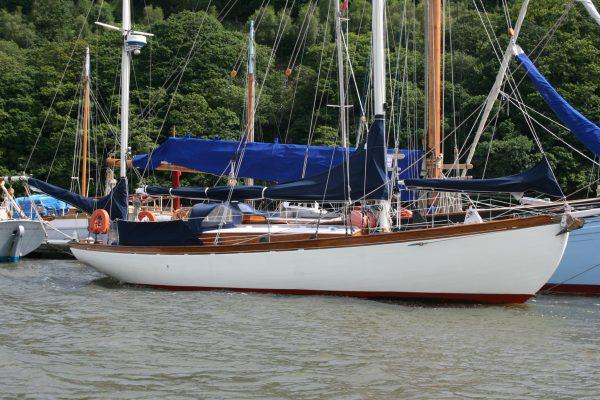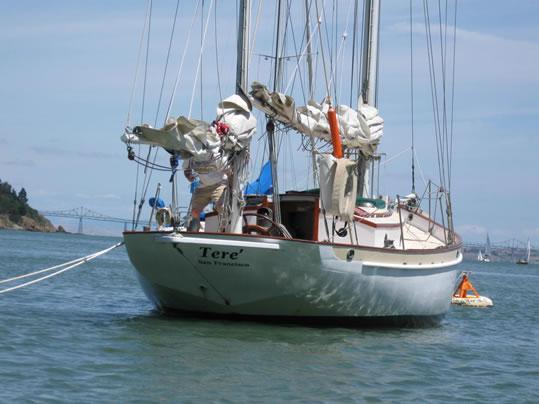The first image is the image on the left, the second image is the image on the right. Considering the images on both sides, is "The image on the left has a boat with at least three of its sails engaged." valid? Answer yes or no. No. The first image is the image on the left, the second image is the image on the right. Given the left and right images, does the statement "There is a sailboat going left with at least two passengers in the boat." hold true? Answer yes or no. No. 